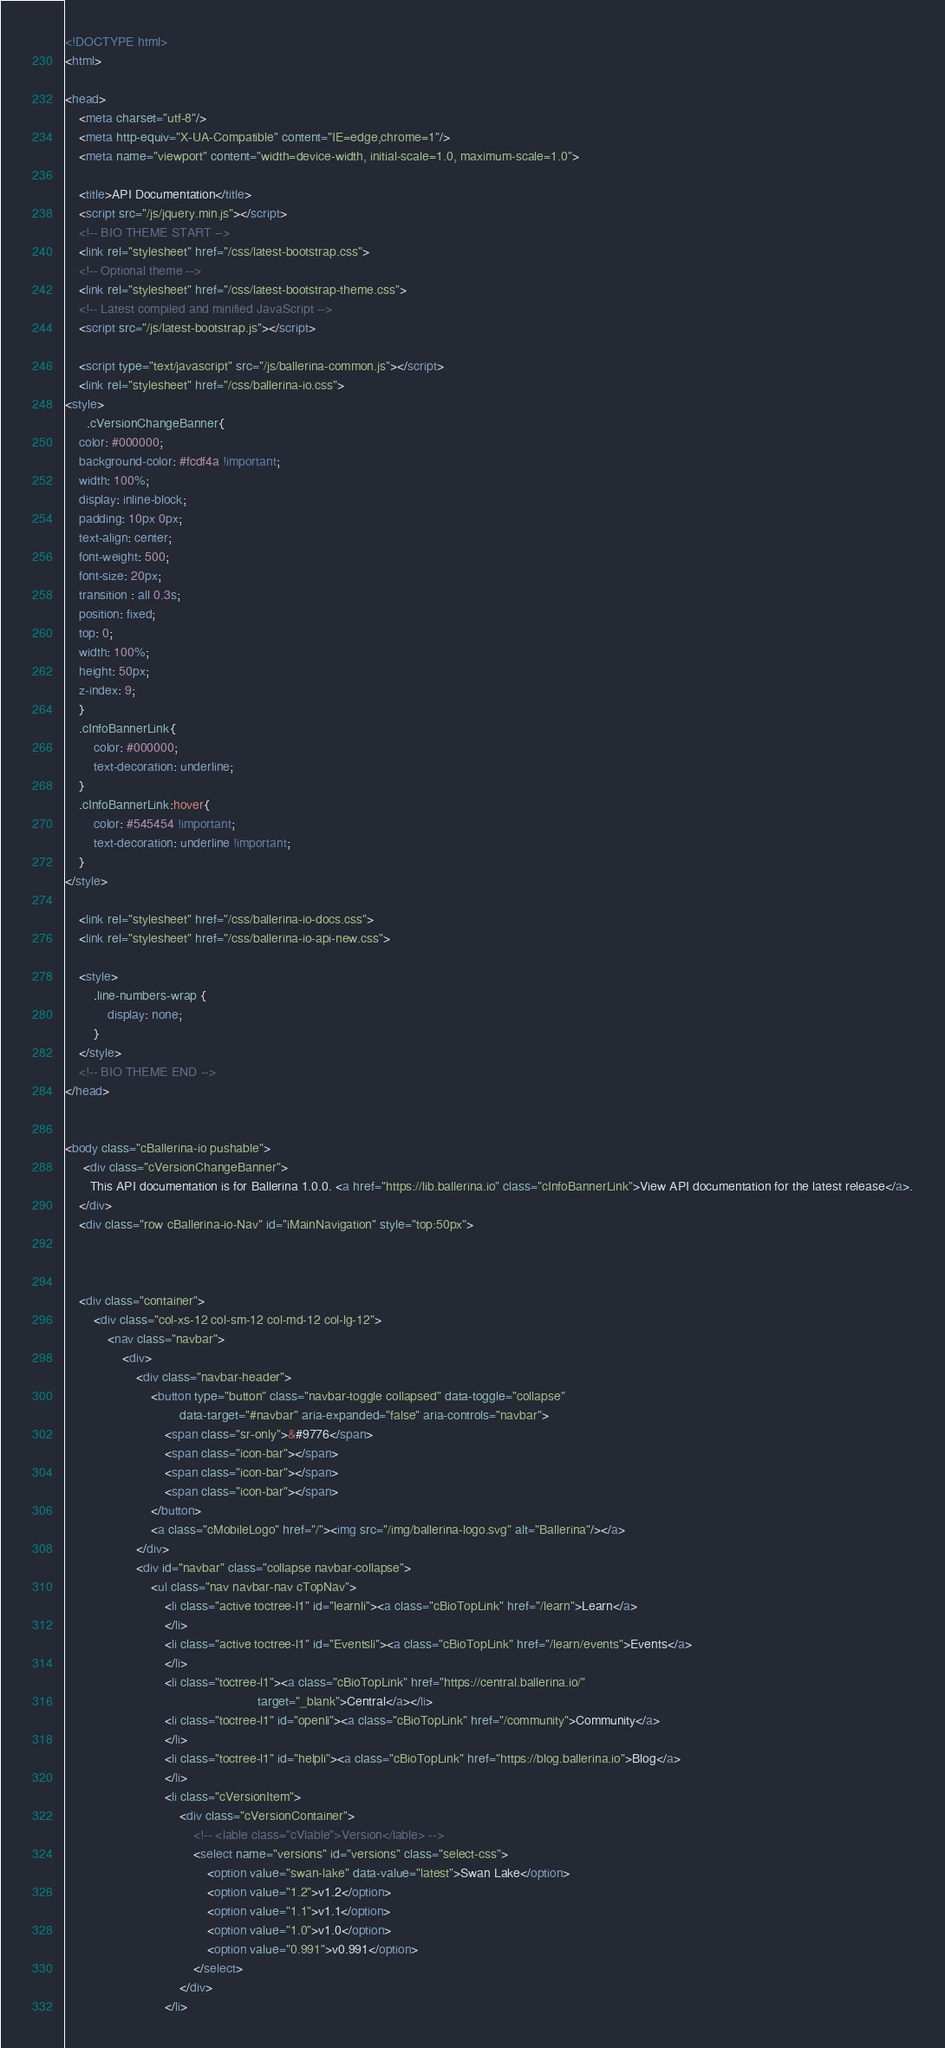<code> <loc_0><loc_0><loc_500><loc_500><_HTML_><!DOCTYPE html>
<html>

<head>
    <meta charset="utf-8"/>
    <meta http-equiv="X-UA-Compatible" content="IE=edge,chrome=1"/>
    <meta name="viewport" content="width=device-width, initial-scale=1.0, maximum-scale=1.0">

    <title>API Documentation</title>
    <script src="/js/jquery.min.js"></script>
    <!-- BIO THEME START -->
    <link rel="stylesheet" href="/css/latest-bootstrap.css">
    <!-- Optional theme -->
    <link rel="stylesheet" href="/css/latest-bootstrap-theme.css">
    <!-- Latest compiled and minified JavaScript -->
    <script src="/js/latest-bootstrap.js"></script>

    <script type="text/javascript" src="/js/ballerina-common.js"></script>
    <link rel="stylesheet" href="/css/ballerina-io.css">
<style>
      .cVersionChangeBanner{
    color: #000000;
    background-color: #fcdf4a !important;
    width: 100%;
    display: inline-block;
    padding: 10px 0px;
    text-align: center;
    font-weight: 500;
    font-size: 20px;
    transition : all 0.3s;
    position: fixed;
    top: 0;
    width: 100%;
    height: 50px;
    z-index: 9;
    }
    .cInfoBannerLink{
        color: #000000;
        text-decoration: underline;
    }
    .cInfoBannerLink:hover{
        color: #545454 !important;
        text-decoration: underline !important;
    }
</style>

    <link rel="stylesheet" href="/css/ballerina-io-docs.css">
    <link rel="stylesheet" href="/css/ballerina-io-api-new.css">

    <style>
        .line-numbers-wrap {
            display: none;
        }
    </style>
    <!-- BIO THEME END -->
</head>


<body class="cBallerina-io pushable">
     <div class="cVersionChangeBanner">
       This API documentation is for Ballerina 1.0.0. <a href="https://lib.ballerina.io" class="cInfoBannerLink">View API documentation for the latest release</a>.
    </div>
    <div class="row cBallerina-io-Nav" id="iMainNavigation" style="top:50px">



    <div class="container">
        <div class="col-xs-12 col-sm-12 col-md-12 col-lg-12">
            <nav class="navbar">
                <div>
                    <div class="navbar-header">
                        <button type="button" class="navbar-toggle collapsed" data-toggle="collapse"
                                data-target="#navbar" aria-expanded="false" aria-controls="navbar">
                            <span class="sr-only">&#9776</span>
                            <span class="icon-bar"></span>
                            <span class="icon-bar"></span>
                            <span class="icon-bar"></span>
                        </button>
                        <a class="cMobileLogo" href="/"><img src="/img/ballerina-logo.svg" alt="Ballerina"/></a>
                    </div>
                    <div id="navbar" class="collapse navbar-collapse">
                        <ul class="nav navbar-nav cTopNav">
                            <li class="active toctree-l1" id="learnli"><a class="cBioTopLink" href="/learn">Learn</a>
                            </li>
                            <li class="active toctree-l1" id="Eventsli"><a class="cBioTopLink" href="/learn/events">Events</a>
                            </li>
                            <li class="toctree-l1"><a class="cBioTopLink" href="https://central.ballerina.io/"
                                                      target="_blank">Central</a></li>
                            <li class="toctree-l1" id="openli"><a class="cBioTopLink" href="/community">Community</a>
                            </li>
                            <li class="toctree-l1" id="helpli"><a class="cBioTopLink" href="https://blog.ballerina.io">Blog</a>
                            </li>
                            <li class="cVersionItem">
                                <div class="cVersionContainer">
                                    <!-- <lable class="cVlable">Version</lable> -->
                                    <select name="versions" id="versions" class="select-css">
                                        <option value="swan-lake" data-value="latest">Swan Lake</option>
                                        <option value="1.2">v1.2</option>
                                        <option value="1.1">v1.1</option>
                                        <option value="1.0">v1.0</option>
                                        <option value="0.991">v0.991</option>
                                    </select>
                                </div>
                            </li></code> 